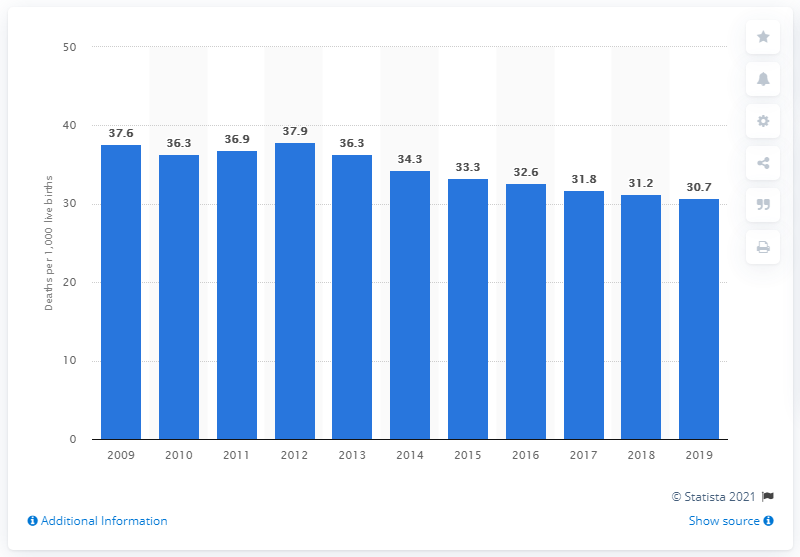Draw attention to some important aspects in this diagram. The infant mortality rate in Namibia in 2019 was 30.7 deaths per 1,000 live births. 